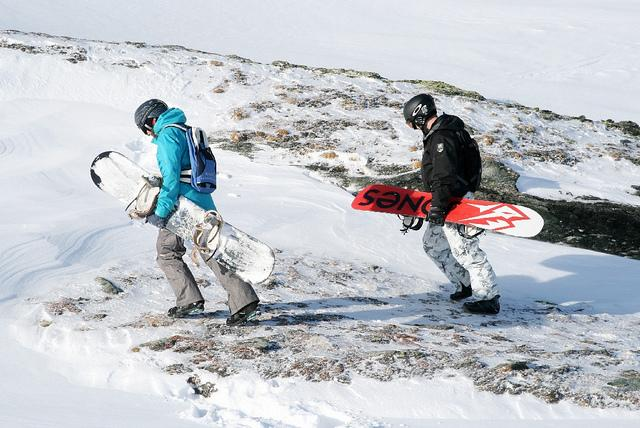What name is on the bottom of the ski board?

Choices:
A) jackson
B) yamaha
C) goose
D) jones jones 